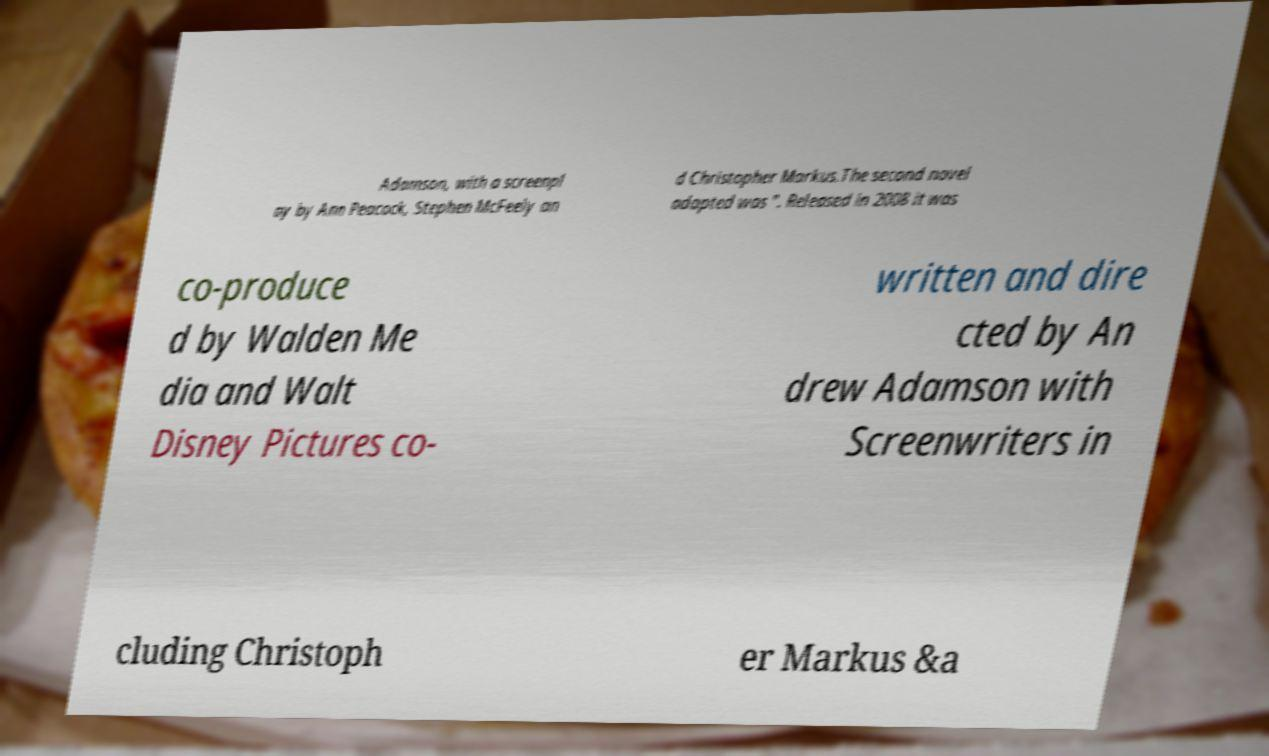I need the written content from this picture converted into text. Can you do that? Adamson, with a screenpl ay by Ann Peacock, Stephen McFeely an d Christopher Markus.The second novel adapted was ". Released in 2008 it was co-produce d by Walden Me dia and Walt Disney Pictures co- written and dire cted by An drew Adamson with Screenwriters in cluding Christoph er Markus &a 